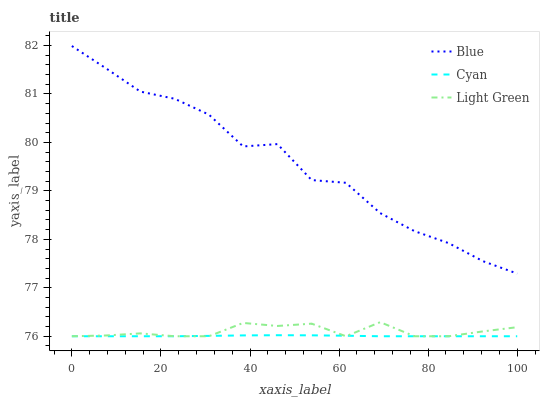Does Cyan have the minimum area under the curve?
Answer yes or no. Yes. Does Blue have the maximum area under the curve?
Answer yes or no. Yes. Does Light Green have the minimum area under the curve?
Answer yes or no. No. Does Light Green have the maximum area under the curve?
Answer yes or no. No. Is Cyan the smoothest?
Answer yes or no. Yes. Is Blue the roughest?
Answer yes or no. Yes. Is Light Green the smoothest?
Answer yes or no. No. Is Light Green the roughest?
Answer yes or no. No. Does Blue have the highest value?
Answer yes or no. Yes. Does Light Green have the highest value?
Answer yes or no. No. Is Cyan less than Blue?
Answer yes or no. Yes. Is Blue greater than Light Green?
Answer yes or no. Yes. Does Light Green intersect Cyan?
Answer yes or no. Yes. Is Light Green less than Cyan?
Answer yes or no. No. Is Light Green greater than Cyan?
Answer yes or no. No. Does Cyan intersect Blue?
Answer yes or no. No. 